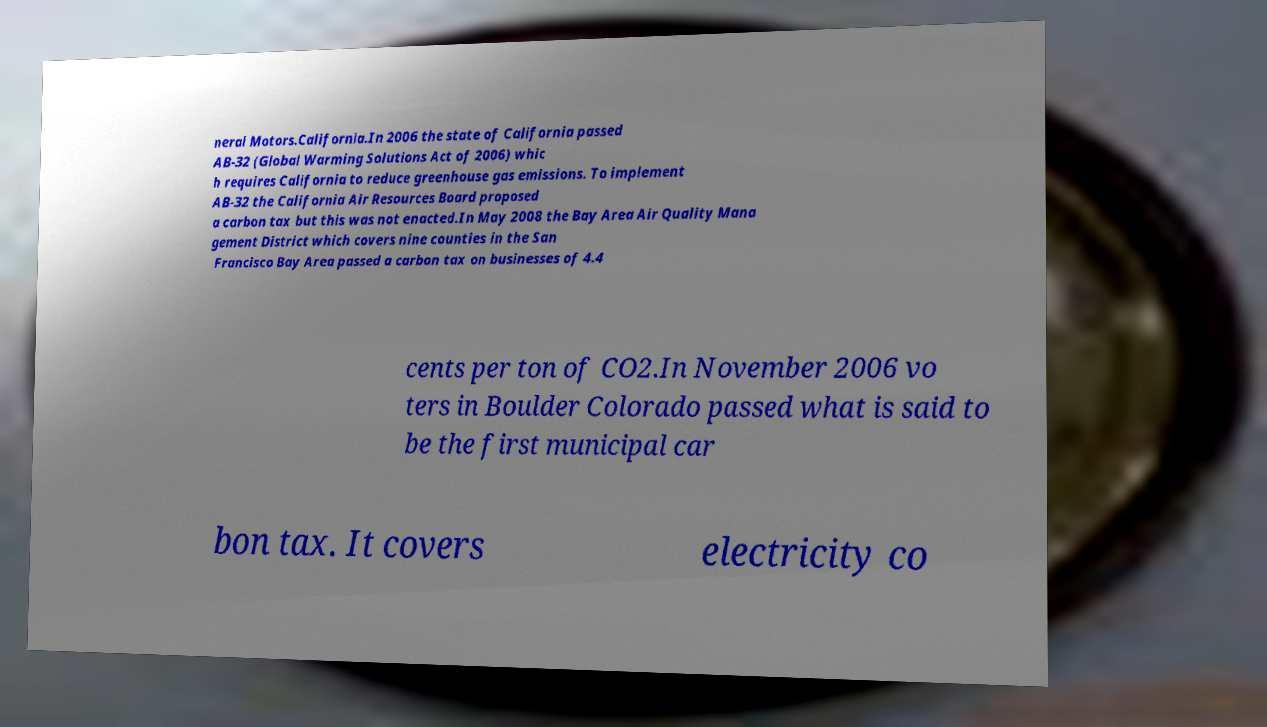What messages or text are displayed in this image? I need them in a readable, typed format. neral Motors.California.In 2006 the state of California passed AB-32 (Global Warming Solutions Act of 2006) whic h requires California to reduce greenhouse gas emissions. To implement AB-32 the California Air Resources Board proposed a carbon tax but this was not enacted.In May 2008 the Bay Area Air Quality Mana gement District which covers nine counties in the San Francisco Bay Area passed a carbon tax on businesses of 4.4 cents per ton of CO2.In November 2006 vo ters in Boulder Colorado passed what is said to be the first municipal car bon tax. It covers electricity co 